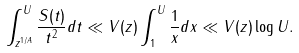Convert formula to latex. <formula><loc_0><loc_0><loc_500><loc_500>\int _ { z ^ { 1 / A } } ^ { U } \frac { S ( t ) } { t ^ { 2 } } d t \ll V ( z ) \int _ { 1 } ^ { U } \frac { 1 } { x } d x \ll V ( z ) \log U .</formula> 